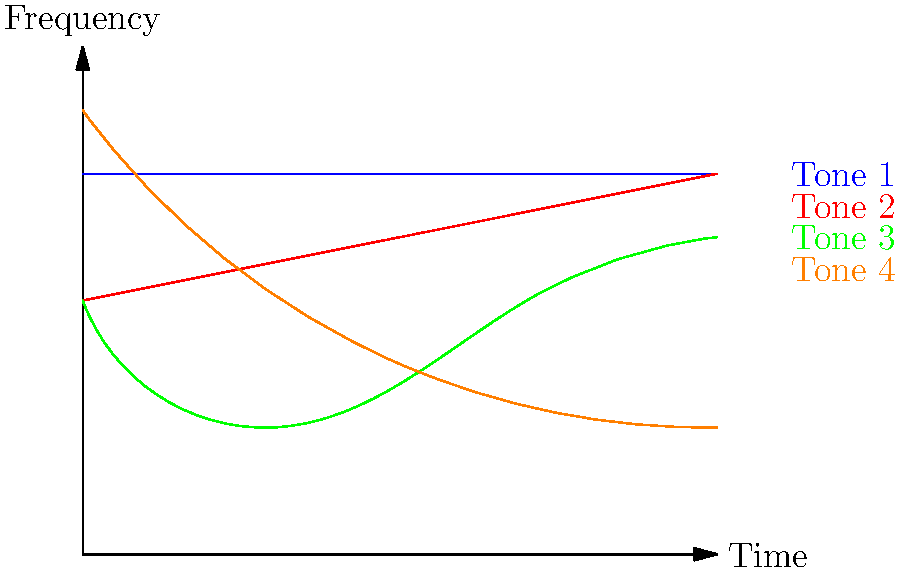Analyze the spectrogram showing the fundamental frequency contours of the four tones in Mandarin Chinese. Which tone is characterized by a falling pitch throughout its duration? To answer this question, we need to examine the pitch contours of each tone represented in the spectrogram:

1. Tone 1 (Blue): Shows a level, high pitch throughout its duration.
2. Tone 2 (Red): Begins with a mid-level pitch and rises towards the end.
3. Tone 3 (Green): Starts mid-level, dips low, and then rises again.
4. Tone 4 (Orange): Begins at a high pitch and falls sharply throughout its duration.

By analyzing these contours, we can see that Tone 4 is the only one that exhibits a consistently falling pitch from start to finish. It begins at the highest point and descends to the lowest point among all tones.

This falling contour is a distinctive feature of Mandarin Chinese Tone 4, often described as a "falling tone" or "high-falling tone" in phonetic literature. It's typically represented in Pinyin with a grave accent (ˋ) over the vowel.
Answer: Tone 4 